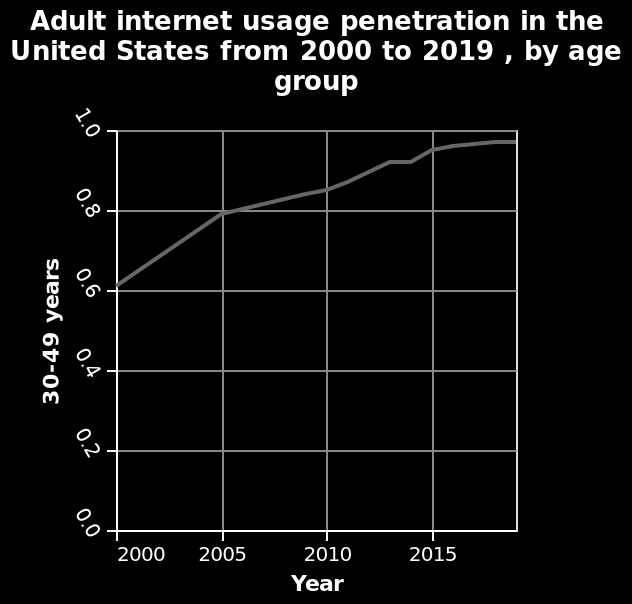<image>
Offer a thorough analysis of the image. The number has increased throughout the graph with its highest point in 2019. 